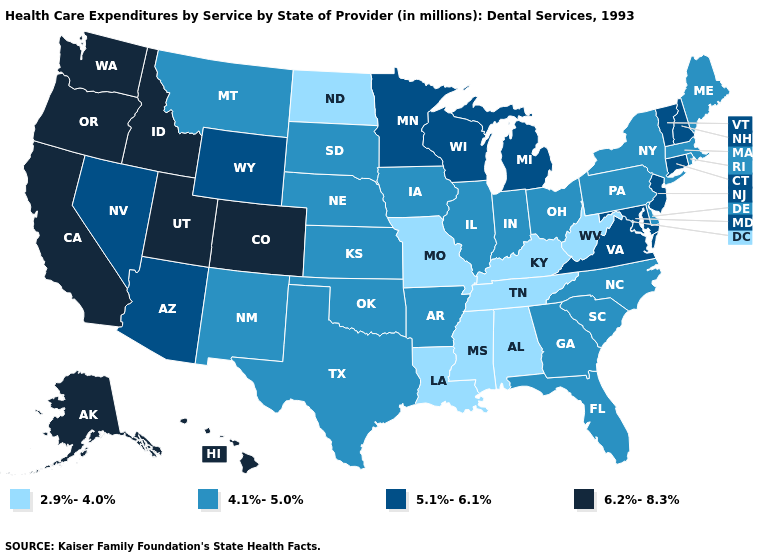Among the states that border North Carolina , does Virginia have the lowest value?
Concise answer only. No. What is the value of Ohio?
Write a very short answer. 4.1%-5.0%. Does Washington have the lowest value in the West?
Answer briefly. No. Which states hav the highest value in the South?
Quick response, please. Maryland, Virginia. What is the lowest value in the MidWest?
Short answer required. 2.9%-4.0%. Name the states that have a value in the range 5.1%-6.1%?
Answer briefly. Arizona, Connecticut, Maryland, Michigan, Minnesota, Nevada, New Hampshire, New Jersey, Vermont, Virginia, Wisconsin, Wyoming. Which states have the lowest value in the USA?
Quick response, please. Alabama, Kentucky, Louisiana, Mississippi, Missouri, North Dakota, Tennessee, West Virginia. What is the value of Vermont?
Be succinct. 5.1%-6.1%. Among the states that border Ohio , which have the highest value?
Concise answer only. Michigan. Name the states that have a value in the range 5.1%-6.1%?
Short answer required. Arizona, Connecticut, Maryland, Michigan, Minnesota, Nevada, New Hampshire, New Jersey, Vermont, Virginia, Wisconsin, Wyoming. Name the states that have a value in the range 4.1%-5.0%?
Give a very brief answer. Arkansas, Delaware, Florida, Georgia, Illinois, Indiana, Iowa, Kansas, Maine, Massachusetts, Montana, Nebraska, New Mexico, New York, North Carolina, Ohio, Oklahoma, Pennsylvania, Rhode Island, South Carolina, South Dakota, Texas. Does the first symbol in the legend represent the smallest category?
Quick response, please. Yes. What is the value of Colorado?
Short answer required. 6.2%-8.3%. Which states have the lowest value in the West?
Answer briefly. Montana, New Mexico. Which states hav the highest value in the South?
Write a very short answer. Maryland, Virginia. 